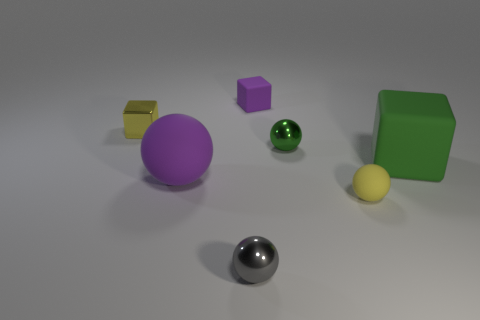Does the large ball have the same color as the tiny rubber block?
Keep it short and to the point. Yes. What shape is the yellow object that is made of the same material as the large block?
Provide a short and direct response. Sphere. Are there more yellow spheres than purple things?
Your answer should be compact. No. Do the green rubber thing and the tiny yellow object that is on the left side of the tiny purple matte object have the same shape?
Give a very brief answer. Yes. What is the material of the small purple object?
Keep it short and to the point. Rubber. What is the color of the metal ball left of the purple rubber object that is right of the matte ball that is to the left of the small green metallic ball?
Offer a very short reply. Gray. What is the material of the large thing that is the same shape as the tiny gray object?
Your answer should be very brief. Rubber. What number of shiny things have the same size as the green sphere?
Offer a very short reply. 2. What number of green objects are there?
Provide a short and direct response. 2. Does the tiny yellow sphere have the same material as the green thing to the left of the big green thing?
Provide a short and direct response. No. 